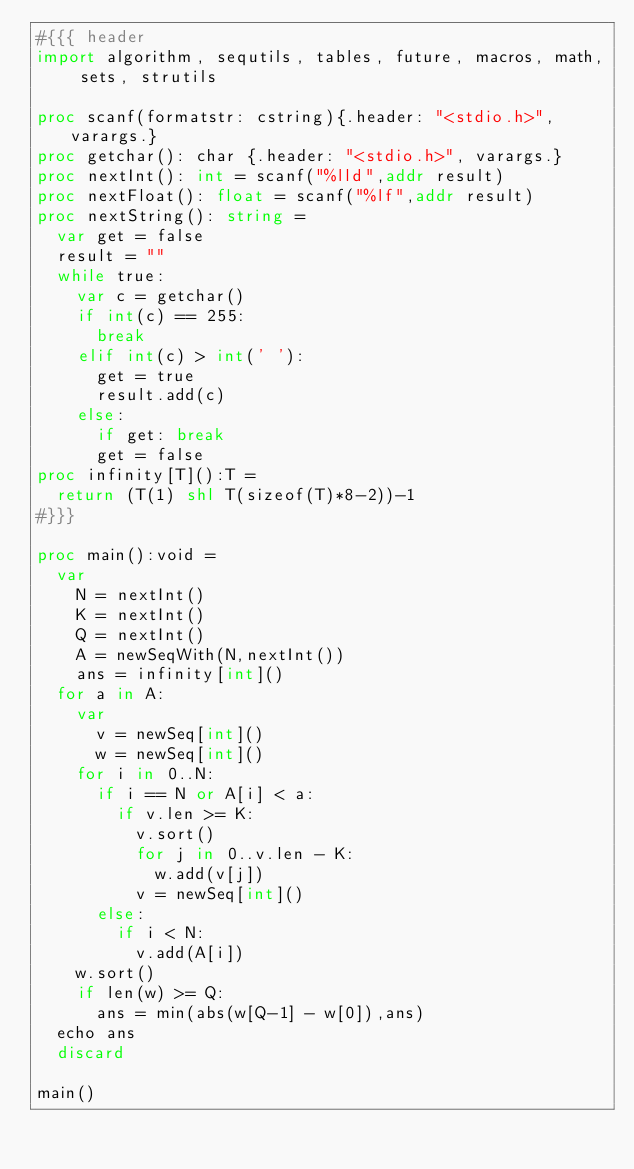Convert code to text. <code><loc_0><loc_0><loc_500><loc_500><_Nim_>#{{{ header
import algorithm, sequtils, tables, future, macros, math, sets, strutils
 
proc scanf(formatstr: cstring){.header: "<stdio.h>", varargs.}
proc getchar(): char {.header: "<stdio.h>", varargs.}
proc nextInt(): int = scanf("%lld",addr result)
proc nextFloat(): float = scanf("%lf",addr result)
proc nextString(): string =
  var get = false
  result = ""
  while true:
    var c = getchar()
    if int(c) == 255:
      break
    elif int(c) > int(' '):
      get = true
      result.add(c)
    else:
      if get: break
      get = false
proc infinity[T]():T =
  return (T(1) shl T(sizeof(T)*8-2))-1
#}}}

proc main():void =
  var
    N = nextInt()
    K = nextInt()
    Q = nextInt()
    A = newSeqWith(N,nextInt())
    ans = infinity[int]()
  for a in A:
    var
      v = newSeq[int]()
      w = newSeq[int]()
    for i in 0..N:
      if i == N or A[i] < a:
        if v.len >= K:
          v.sort()
          for j in 0..v.len - K:
            w.add(v[j])
          v = newSeq[int]()
      else:
        if i < N:
          v.add(A[i])
    w.sort()
    if len(w) >= Q:
      ans = min(abs(w[Q-1] - w[0]),ans)
  echo ans
  discard

main()
</code> 